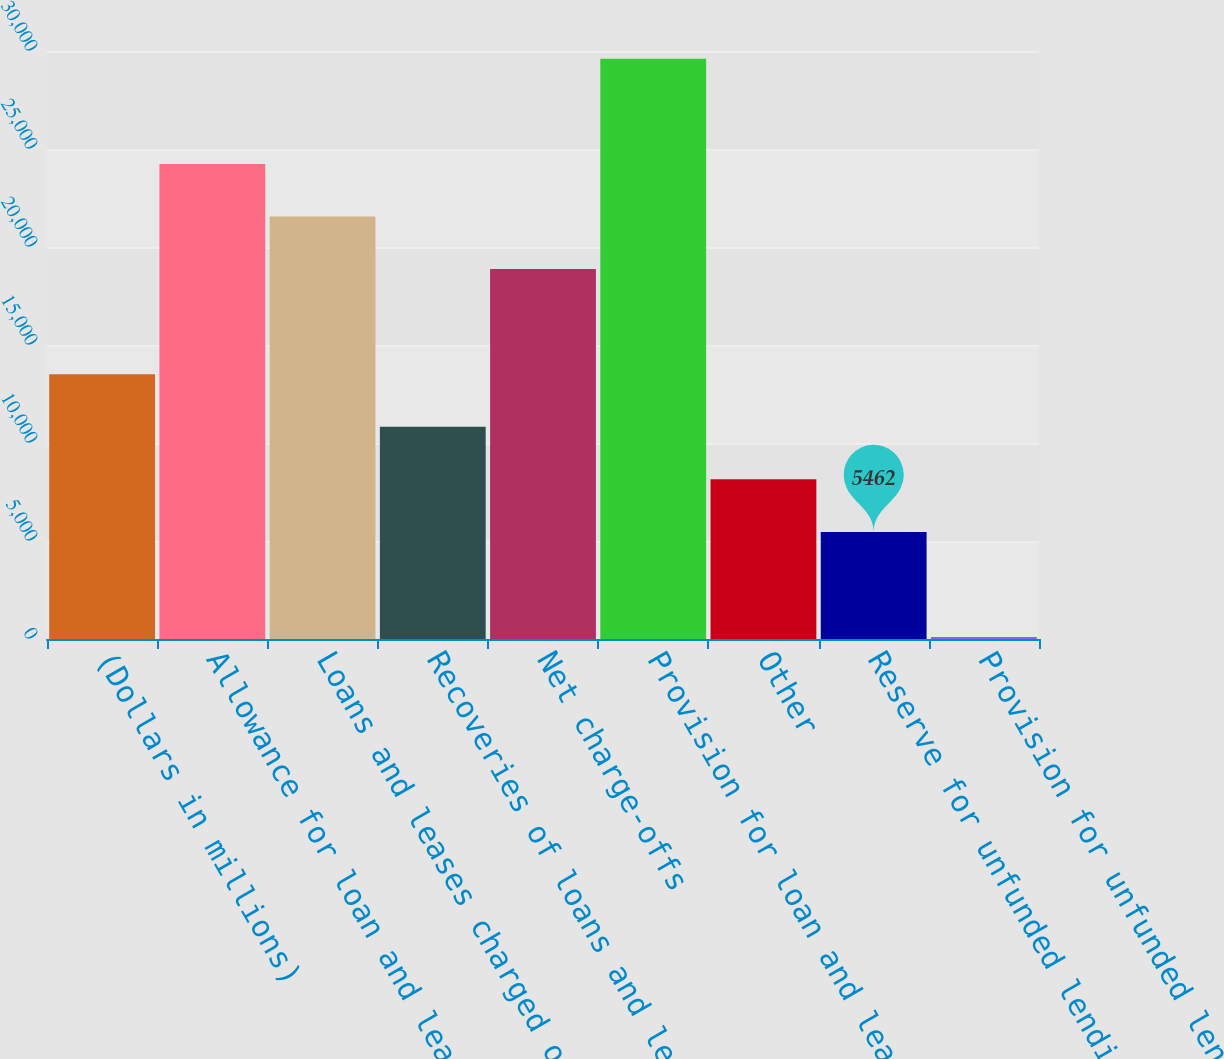Convert chart to OTSL. <chart><loc_0><loc_0><loc_500><loc_500><bar_chart><fcel>(Dollars in millions)<fcel>Allowance for loan and lease<fcel>Loans and leases charged off<fcel>Recoveries of loans and leases<fcel>Net charge-offs<fcel>Provision for loan and lease<fcel>Other<fcel>Reserve for unfunded lending<fcel>Provision for unfunded lending<nl><fcel>13509.5<fcel>24239.5<fcel>21557<fcel>10827<fcel>18874.5<fcel>29604.5<fcel>8144.5<fcel>5462<fcel>97<nl></chart> 